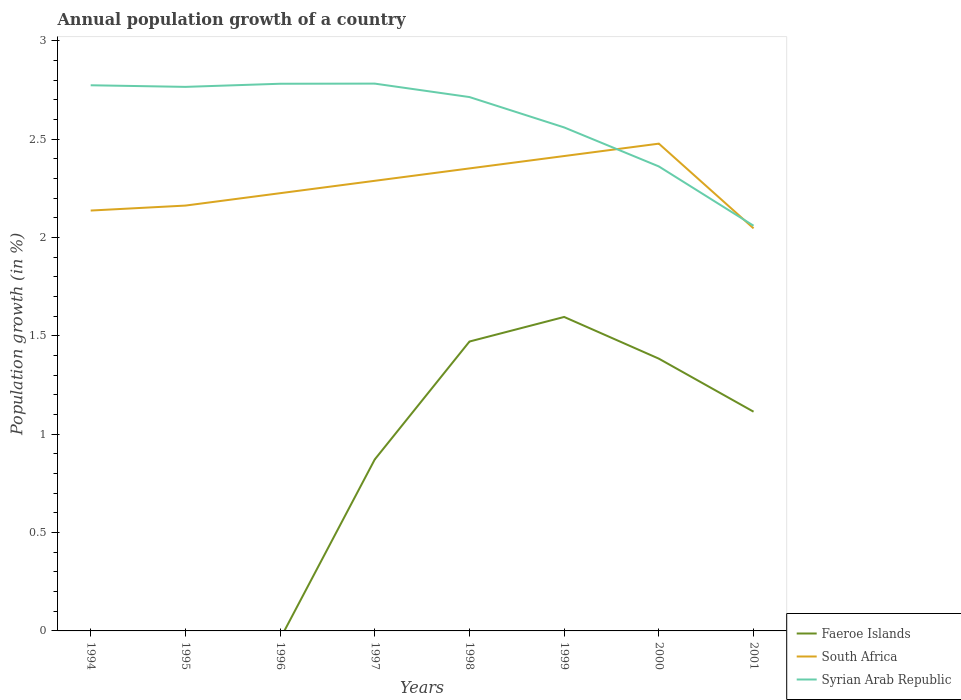How many different coloured lines are there?
Offer a very short reply. 3. Across all years, what is the maximum annual population growth in Faeroe Islands?
Your answer should be compact. 0. What is the total annual population growth in South Africa in the graph?
Provide a succinct answer. -0.15. What is the difference between the highest and the second highest annual population growth in Faeroe Islands?
Ensure brevity in your answer.  1.6. Is the annual population growth in South Africa strictly greater than the annual population growth in Faeroe Islands over the years?
Your answer should be very brief. No. Where does the legend appear in the graph?
Offer a terse response. Bottom right. How many legend labels are there?
Offer a very short reply. 3. How are the legend labels stacked?
Your answer should be very brief. Vertical. What is the title of the graph?
Provide a succinct answer. Annual population growth of a country. What is the label or title of the Y-axis?
Ensure brevity in your answer.  Population growth (in %). What is the Population growth (in %) in Faeroe Islands in 1994?
Your answer should be compact. 0. What is the Population growth (in %) of South Africa in 1994?
Provide a succinct answer. 2.14. What is the Population growth (in %) of Syrian Arab Republic in 1994?
Offer a terse response. 2.77. What is the Population growth (in %) of Faeroe Islands in 1995?
Make the answer very short. 0. What is the Population growth (in %) of South Africa in 1995?
Provide a succinct answer. 2.16. What is the Population growth (in %) of Syrian Arab Republic in 1995?
Provide a succinct answer. 2.77. What is the Population growth (in %) of South Africa in 1996?
Provide a short and direct response. 2.23. What is the Population growth (in %) of Syrian Arab Republic in 1996?
Your answer should be very brief. 2.78. What is the Population growth (in %) in Faeroe Islands in 1997?
Offer a terse response. 0.87. What is the Population growth (in %) of South Africa in 1997?
Offer a terse response. 2.29. What is the Population growth (in %) in Syrian Arab Republic in 1997?
Ensure brevity in your answer.  2.78. What is the Population growth (in %) in Faeroe Islands in 1998?
Ensure brevity in your answer.  1.47. What is the Population growth (in %) of South Africa in 1998?
Give a very brief answer. 2.35. What is the Population growth (in %) of Syrian Arab Republic in 1998?
Your answer should be compact. 2.71. What is the Population growth (in %) of Faeroe Islands in 1999?
Give a very brief answer. 1.6. What is the Population growth (in %) of South Africa in 1999?
Offer a terse response. 2.41. What is the Population growth (in %) of Syrian Arab Republic in 1999?
Ensure brevity in your answer.  2.56. What is the Population growth (in %) of Faeroe Islands in 2000?
Offer a terse response. 1.38. What is the Population growth (in %) in South Africa in 2000?
Offer a very short reply. 2.48. What is the Population growth (in %) of Syrian Arab Republic in 2000?
Your response must be concise. 2.36. What is the Population growth (in %) of Faeroe Islands in 2001?
Offer a very short reply. 1.11. What is the Population growth (in %) of South Africa in 2001?
Provide a succinct answer. 2.05. What is the Population growth (in %) in Syrian Arab Republic in 2001?
Give a very brief answer. 2.06. Across all years, what is the maximum Population growth (in %) of Faeroe Islands?
Your answer should be compact. 1.6. Across all years, what is the maximum Population growth (in %) in South Africa?
Your answer should be compact. 2.48. Across all years, what is the maximum Population growth (in %) in Syrian Arab Republic?
Make the answer very short. 2.78. Across all years, what is the minimum Population growth (in %) of Faeroe Islands?
Offer a terse response. 0. Across all years, what is the minimum Population growth (in %) of South Africa?
Provide a succinct answer. 2.05. Across all years, what is the minimum Population growth (in %) in Syrian Arab Republic?
Provide a succinct answer. 2.06. What is the total Population growth (in %) in Faeroe Islands in the graph?
Provide a short and direct response. 6.44. What is the total Population growth (in %) in South Africa in the graph?
Keep it short and to the point. 18.1. What is the total Population growth (in %) in Syrian Arab Republic in the graph?
Offer a terse response. 20.8. What is the difference between the Population growth (in %) in South Africa in 1994 and that in 1995?
Offer a very short reply. -0.03. What is the difference between the Population growth (in %) in Syrian Arab Republic in 1994 and that in 1995?
Your answer should be compact. 0.01. What is the difference between the Population growth (in %) of South Africa in 1994 and that in 1996?
Your answer should be compact. -0.09. What is the difference between the Population growth (in %) in Syrian Arab Republic in 1994 and that in 1996?
Make the answer very short. -0.01. What is the difference between the Population growth (in %) of South Africa in 1994 and that in 1997?
Provide a succinct answer. -0.15. What is the difference between the Population growth (in %) of Syrian Arab Republic in 1994 and that in 1997?
Your response must be concise. -0.01. What is the difference between the Population growth (in %) of South Africa in 1994 and that in 1998?
Ensure brevity in your answer.  -0.21. What is the difference between the Population growth (in %) of Syrian Arab Republic in 1994 and that in 1998?
Make the answer very short. 0.06. What is the difference between the Population growth (in %) in South Africa in 1994 and that in 1999?
Provide a succinct answer. -0.28. What is the difference between the Population growth (in %) in Syrian Arab Republic in 1994 and that in 1999?
Your answer should be very brief. 0.21. What is the difference between the Population growth (in %) in South Africa in 1994 and that in 2000?
Offer a terse response. -0.34. What is the difference between the Population growth (in %) in Syrian Arab Republic in 1994 and that in 2000?
Make the answer very short. 0.41. What is the difference between the Population growth (in %) of South Africa in 1994 and that in 2001?
Ensure brevity in your answer.  0.09. What is the difference between the Population growth (in %) of Syrian Arab Republic in 1994 and that in 2001?
Provide a succinct answer. 0.71. What is the difference between the Population growth (in %) of South Africa in 1995 and that in 1996?
Provide a short and direct response. -0.06. What is the difference between the Population growth (in %) of Syrian Arab Republic in 1995 and that in 1996?
Give a very brief answer. -0.02. What is the difference between the Population growth (in %) in South Africa in 1995 and that in 1997?
Provide a succinct answer. -0.13. What is the difference between the Population growth (in %) of Syrian Arab Republic in 1995 and that in 1997?
Make the answer very short. -0.02. What is the difference between the Population growth (in %) of South Africa in 1995 and that in 1998?
Provide a short and direct response. -0.19. What is the difference between the Population growth (in %) in Syrian Arab Republic in 1995 and that in 1998?
Offer a terse response. 0.05. What is the difference between the Population growth (in %) of South Africa in 1995 and that in 1999?
Give a very brief answer. -0.25. What is the difference between the Population growth (in %) of Syrian Arab Republic in 1995 and that in 1999?
Provide a short and direct response. 0.21. What is the difference between the Population growth (in %) in South Africa in 1995 and that in 2000?
Provide a short and direct response. -0.31. What is the difference between the Population growth (in %) of Syrian Arab Republic in 1995 and that in 2000?
Make the answer very short. 0.4. What is the difference between the Population growth (in %) in South Africa in 1995 and that in 2001?
Provide a succinct answer. 0.12. What is the difference between the Population growth (in %) of Syrian Arab Republic in 1995 and that in 2001?
Make the answer very short. 0.71. What is the difference between the Population growth (in %) of South Africa in 1996 and that in 1997?
Keep it short and to the point. -0.06. What is the difference between the Population growth (in %) in Syrian Arab Republic in 1996 and that in 1997?
Ensure brevity in your answer.  -0. What is the difference between the Population growth (in %) of South Africa in 1996 and that in 1998?
Your answer should be very brief. -0.13. What is the difference between the Population growth (in %) of Syrian Arab Republic in 1996 and that in 1998?
Your answer should be compact. 0.07. What is the difference between the Population growth (in %) in South Africa in 1996 and that in 1999?
Provide a short and direct response. -0.19. What is the difference between the Population growth (in %) of Syrian Arab Republic in 1996 and that in 1999?
Provide a succinct answer. 0.22. What is the difference between the Population growth (in %) in South Africa in 1996 and that in 2000?
Provide a succinct answer. -0.25. What is the difference between the Population growth (in %) in Syrian Arab Republic in 1996 and that in 2000?
Ensure brevity in your answer.  0.42. What is the difference between the Population growth (in %) of South Africa in 1996 and that in 2001?
Offer a terse response. 0.18. What is the difference between the Population growth (in %) of Syrian Arab Republic in 1996 and that in 2001?
Give a very brief answer. 0.72. What is the difference between the Population growth (in %) of Faeroe Islands in 1997 and that in 1998?
Provide a succinct answer. -0.6. What is the difference between the Population growth (in %) of South Africa in 1997 and that in 1998?
Your answer should be compact. -0.06. What is the difference between the Population growth (in %) in Syrian Arab Republic in 1997 and that in 1998?
Make the answer very short. 0.07. What is the difference between the Population growth (in %) of Faeroe Islands in 1997 and that in 1999?
Provide a succinct answer. -0.72. What is the difference between the Population growth (in %) in South Africa in 1997 and that in 1999?
Make the answer very short. -0.13. What is the difference between the Population growth (in %) of Syrian Arab Republic in 1997 and that in 1999?
Offer a terse response. 0.22. What is the difference between the Population growth (in %) in Faeroe Islands in 1997 and that in 2000?
Your response must be concise. -0.51. What is the difference between the Population growth (in %) of South Africa in 1997 and that in 2000?
Your response must be concise. -0.19. What is the difference between the Population growth (in %) of Syrian Arab Republic in 1997 and that in 2000?
Offer a terse response. 0.42. What is the difference between the Population growth (in %) in Faeroe Islands in 1997 and that in 2001?
Your answer should be compact. -0.24. What is the difference between the Population growth (in %) of South Africa in 1997 and that in 2001?
Offer a terse response. 0.24. What is the difference between the Population growth (in %) in Syrian Arab Republic in 1997 and that in 2001?
Keep it short and to the point. 0.72. What is the difference between the Population growth (in %) of Faeroe Islands in 1998 and that in 1999?
Make the answer very short. -0.12. What is the difference between the Population growth (in %) in South Africa in 1998 and that in 1999?
Provide a succinct answer. -0.06. What is the difference between the Population growth (in %) in Syrian Arab Republic in 1998 and that in 1999?
Your answer should be very brief. 0.15. What is the difference between the Population growth (in %) of Faeroe Islands in 1998 and that in 2000?
Your response must be concise. 0.09. What is the difference between the Population growth (in %) in South Africa in 1998 and that in 2000?
Provide a succinct answer. -0.13. What is the difference between the Population growth (in %) of Syrian Arab Republic in 1998 and that in 2000?
Your answer should be very brief. 0.35. What is the difference between the Population growth (in %) in Faeroe Islands in 1998 and that in 2001?
Keep it short and to the point. 0.36. What is the difference between the Population growth (in %) of South Africa in 1998 and that in 2001?
Your answer should be very brief. 0.3. What is the difference between the Population growth (in %) in Syrian Arab Republic in 1998 and that in 2001?
Your answer should be compact. 0.65. What is the difference between the Population growth (in %) in Faeroe Islands in 1999 and that in 2000?
Ensure brevity in your answer.  0.21. What is the difference between the Population growth (in %) in South Africa in 1999 and that in 2000?
Your answer should be very brief. -0.06. What is the difference between the Population growth (in %) of Syrian Arab Republic in 1999 and that in 2000?
Keep it short and to the point. 0.2. What is the difference between the Population growth (in %) in Faeroe Islands in 1999 and that in 2001?
Ensure brevity in your answer.  0.48. What is the difference between the Population growth (in %) of South Africa in 1999 and that in 2001?
Make the answer very short. 0.37. What is the difference between the Population growth (in %) of Syrian Arab Republic in 1999 and that in 2001?
Keep it short and to the point. 0.5. What is the difference between the Population growth (in %) of Faeroe Islands in 2000 and that in 2001?
Your answer should be compact. 0.27. What is the difference between the Population growth (in %) in South Africa in 2000 and that in 2001?
Your answer should be compact. 0.43. What is the difference between the Population growth (in %) of Syrian Arab Republic in 2000 and that in 2001?
Your response must be concise. 0.3. What is the difference between the Population growth (in %) of South Africa in 1994 and the Population growth (in %) of Syrian Arab Republic in 1995?
Make the answer very short. -0.63. What is the difference between the Population growth (in %) of South Africa in 1994 and the Population growth (in %) of Syrian Arab Republic in 1996?
Your answer should be compact. -0.64. What is the difference between the Population growth (in %) of South Africa in 1994 and the Population growth (in %) of Syrian Arab Republic in 1997?
Ensure brevity in your answer.  -0.65. What is the difference between the Population growth (in %) in South Africa in 1994 and the Population growth (in %) in Syrian Arab Republic in 1998?
Provide a short and direct response. -0.58. What is the difference between the Population growth (in %) in South Africa in 1994 and the Population growth (in %) in Syrian Arab Republic in 1999?
Keep it short and to the point. -0.42. What is the difference between the Population growth (in %) of South Africa in 1994 and the Population growth (in %) of Syrian Arab Republic in 2000?
Offer a terse response. -0.22. What is the difference between the Population growth (in %) of South Africa in 1994 and the Population growth (in %) of Syrian Arab Republic in 2001?
Give a very brief answer. 0.08. What is the difference between the Population growth (in %) in South Africa in 1995 and the Population growth (in %) in Syrian Arab Republic in 1996?
Your answer should be compact. -0.62. What is the difference between the Population growth (in %) of South Africa in 1995 and the Population growth (in %) of Syrian Arab Republic in 1997?
Give a very brief answer. -0.62. What is the difference between the Population growth (in %) of South Africa in 1995 and the Population growth (in %) of Syrian Arab Republic in 1998?
Ensure brevity in your answer.  -0.55. What is the difference between the Population growth (in %) in South Africa in 1995 and the Population growth (in %) in Syrian Arab Republic in 1999?
Make the answer very short. -0.4. What is the difference between the Population growth (in %) in South Africa in 1995 and the Population growth (in %) in Syrian Arab Republic in 2000?
Provide a succinct answer. -0.2. What is the difference between the Population growth (in %) of South Africa in 1995 and the Population growth (in %) of Syrian Arab Republic in 2001?
Your answer should be very brief. 0.1. What is the difference between the Population growth (in %) in South Africa in 1996 and the Population growth (in %) in Syrian Arab Republic in 1997?
Your answer should be compact. -0.56. What is the difference between the Population growth (in %) in South Africa in 1996 and the Population growth (in %) in Syrian Arab Republic in 1998?
Give a very brief answer. -0.49. What is the difference between the Population growth (in %) of South Africa in 1996 and the Population growth (in %) of Syrian Arab Republic in 1999?
Provide a short and direct response. -0.33. What is the difference between the Population growth (in %) in South Africa in 1996 and the Population growth (in %) in Syrian Arab Republic in 2000?
Your answer should be very brief. -0.14. What is the difference between the Population growth (in %) of South Africa in 1996 and the Population growth (in %) of Syrian Arab Republic in 2001?
Give a very brief answer. 0.17. What is the difference between the Population growth (in %) of Faeroe Islands in 1997 and the Population growth (in %) of South Africa in 1998?
Keep it short and to the point. -1.48. What is the difference between the Population growth (in %) of Faeroe Islands in 1997 and the Population growth (in %) of Syrian Arab Republic in 1998?
Your answer should be compact. -1.84. What is the difference between the Population growth (in %) of South Africa in 1997 and the Population growth (in %) of Syrian Arab Republic in 1998?
Your answer should be very brief. -0.43. What is the difference between the Population growth (in %) in Faeroe Islands in 1997 and the Population growth (in %) in South Africa in 1999?
Offer a very short reply. -1.54. What is the difference between the Population growth (in %) of Faeroe Islands in 1997 and the Population growth (in %) of Syrian Arab Republic in 1999?
Make the answer very short. -1.69. What is the difference between the Population growth (in %) of South Africa in 1997 and the Population growth (in %) of Syrian Arab Republic in 1999?
Your response must be concise. -0.27. What is the difference between the Population growth (in %) in Faeroe Islands in 1997 and the Population growth (in %) in South Africa in 2000?
Keep it short and to the point. -1.61. What is the difference between the Population growth (in %) of Faeroe Islands in 1997 and the Population growth (in %) of Syrian Arab Republic in 2000?
Offer a terse response. -1.49. What is the difference between the Population growth (in %) of South Africa in 1997 and the Population growth (in %) of Syrian Arab Republic in 2000?
Offer a terse response. -0.07. What is the difference between the Population growth (in %) of Faeroe Islands in 1997 and the Population growth (in %) of South Africa in 2001?
Offer a very short reply. -1.17. What is the difference between the Population growth (in %) in Faeroe Islands in 1997 and the Population growth (in %) in Syrian Arab Republic in 2001?
Your answer should be very brief. -1.19. What is the difference between the Population growth (in %) of South Africa in 1997 and the Population growth (in %) of Syrian Arab Republic in 2001?
Provide a succinct answer. 0.23. What is the difference between the Population growth (in %) in Faeroe Islands in 1998 and the Population growth (in %) in South Africa in 1999?
Offer a very short reply. -0.94. What is the difference between the Population growth (in %) in Faeroe Islands in 1998 and the Population growth (in %) in Syrian Arab Republic in 1999?
Offer a very short reply. -1.09. What is the difference between the Population growth (in %) in South Africa in 1998 and the Population growth (in %) in Syrian Arab Republic in 1999?
Ensure brevity in your answer.  -0.21. What is the difference between the Population growth (in %) in Faeroe Islands in 1998 and the Population growth (in %) in South Africa in 2000?
Give a very brief answer. -1.01. What is the difference between the Population growth (in %) in Faeroe Islands in 1998 and the Population growth (in %) in Syrian Arab Republic in 2000?
Your answer should be very brief. -0.89. What is the difference between the Population growth (in %) in South Africa in 1998 and the Population growth (in %) in Syrian Arab Republic in 2000?
Provide a short and direct response. -0.01. What is the difference between the Population growth (in %) of Faeroe Islands in 1998 and the Population growth (in %) of South Africa in 2001?
Provide a succinct answer. -0.58. What is the difference between the Population growth (in %) in Faeroe Islands in 1998 and the Population growth (in %) in Syrian Arab Republic in 2001?
Give a very brief answer. -0.59. What is the difference between the Population growth (in %) in South Africa in 1998 and the Population growth (in %) in Syrian Arab Republic in 2001?
Provide a short and direct response. 0.29. What is the difference between the Population growth (in %) in Faeroe Islands in 1999 and the Population growth (in %) in South Africa in 2000?
Keep it short and to the point. -0.88. What is the difference between the Population growth (in %) of Faeroe Islands in 1999 and the Population growth (in %) of Syrian Arab Republic in 2000?
Keep it short and to the point. -0.77. What is the difference between the Population growth (in %) in South Africa in 1999 and the Population growth (in %) in Syrian Arab Republic in 2000?
Your response must be concise. 0.05. What is the difference between the Population growth (in %) of Faeroe Islands in 1999 and the Population growth (in %) of South Africa in 2001?
Provide a succinct answer. -0.45. What is the difference between the Population growth (in %) of Faeroe Islands in 1999 and the Population growth (in %) of Syrian Arab Republic in 2001?
Give a very brief answer. -0.46. What is the difference between the Population growth (in %) in South Africa in 1999 and the Population growth (in %) in Syrian Arab Republic in 2001?
Offer a very short reply. 0.35. What is the difference between the Population growth (in %) in Faeroe Islands in 2000 and the Population growth (in %) in South Africa in 2001?
Offer a terse response. -0.66. What is the difference between the Population growth (in %) in Faeroe Islands in 2000 and the Population growth (in %) in Syrian Arab Republic in 2001?
Keep it short and to the point. -0.68. What is the difference between the Population growth (in %) in South Africa in 2000 and the Population growth (in %) in Syrian Arab Republic in 2001?
Provide a succinct answer. 0.42. What is the average Population growth (in %) of Faeroe Islands per year?
Your answer should be compact. 0.8. What is the average Population growth (in %) of South Africa per year?
Make the answer very short. 2.26. What is the average Population growth (in %) of Syrian Arab Republic per year?
Give a very brief answer. 2.6. In the year 1994, what is the difference between the Population growth (in %) in South Africa and Population growth (in %) in Syrian Arab Republic?
Offer a very short reply. -0.64. In the year 1995, what is the difference between the Population growth (in %) of South Africa and Population growth (in %) of Syrian Arab Republic?
Keep it short and to the point. -0.6. In the year 1996, what is the difference between the Population growth (in %) of South Africa and Population growth (in %) of Syrian Arab Republic?
Ensure brevity in your answer.  -0.56. In the year 1997, what is the difference between the Population growth (in %) of Faeroe Islands and Population growth (in %) of South Africa?
Offer a terse response. -1.42. In the year 1997, what is the difference between the Population growth (in %) of Faeroe Islands and Population growth (in %) of Syrian Arab Republic?
Your answer should be very brief. -1.91. In the year 1997, what is the difference between the Population growth (in %) of South Africa and Population growth (in %) of Syrian Arab Republic?
Offer a very short reply. -0.49. In the year 1998, what is the difference between the Population growth (in %) of Faeroe Islands and Population growth (in %) of South Africa?
Give a very brief answer. -0.88. In the year 1998, what is the difference between the Population growth (in %) in Faeroe Islands and Population growth (in %) in Syrian Arab Republic?
Provide a succinct answer. -1.24. In the year 1998, what is the difference between the Population growth (in %) of South Africa and Population growth (in %) of Syrian Arab Republic?
Your response must be concise. -0.36. In the year 1999, what is the difference between the Population growth (in %) in Faeroe Islands and Population growth (in %) in South Africa?
Keep it short and to the point. -0.82. In the year 1999, what is the difference between the Population growth (in %) of Faeroe Islands and Population growth (in %) of Syrian Arab Republic?
Make the answer very short. -0.96. In the year 1999, what is the difference between the Population growth (in %) in South Africa and Population growth (in %) in Syrian Arab Republic?
Your response must be concise. -0.15. In the year 2000, what is the difference between the Population growth (in %) in Faeroe Islands and Population growth (in %) in South Africa?
Your answer should be compact. -1.09. In the year 2000, what is the difference between the Population growth (in %) of Faeroe Islands and Population growth (in %) of Syrian Arab Republic?
Offer a very short reply. -0.98. In the year 2000, what is the difference between the Population growth (in %) in South Africa and Population growth (in %) in Syrian Arab Republic?
Keep it short and to the point. 0.12. In the year 2001, what is the difference between the Population growth (in %) of Faeroe Islands and Population growth (in %) of South Africa?
Your response must be concise. -0.93. In the year 2001, what is the difference between the Population growth (in %) in Faeroe Islands and Population growth (in %) in Syrian Arab Republic?
Your answer should be compact. -0.95. In the year 2001, what is the difference between the Population growth (in %) of South Africa and Population growth (in %) of Syrian Arab Republic?
Your answer should be compact. -0.01. What is the ratio of the Population growth (in %) in South Africa in 1994 to that in 1995?
Offer a terse response. 0.99. What is the ratio of the Population growth (in %) of South Africa in 1994 to that in 1996?
Provide a succinct answer. 0.96. What is the ratio of the Population growth (in %) of Syrian Arab Republic in 1994 to that in 1996?
Your response must be concise. 1. What is the ratio of the Population growth (in %) of South Africa in 1994 to that in 1997?
Your answer should be very brief. 0.93. What is the ratio of the Population growth (in %) in South Africa in 1994 to that in 1998?
Offer a terse response. 0.91. What is the ratio of the Population growth (in %) of Syrian Arab Republic in 1994 to that in 1998?
Offer a terse response. 1.02. What is the ratio of the Population growth (in %) of South Africa in 1994 to that in 1999?
Keep it short and to the point. 0.89. What is the ratio of the Population growth (in %) in Syrian Arab Republic in 1994 to that in 1999?
Your answer should be very brief. 1.08. What is the ratio of the Population growth (in %) of South Africa in 1994 to that in 2000?
Give a very brief answer. 0.86. What is the ratio of the Population growth (in %) of Syrian Arab Republic in 1994 to that in 2000?
Ensure brevity in your answer.  1.17. What is the ratio of the Population growth (in %) of South Africa in 1994 to that in 2001?
Your answer should be very brief. 1.04. What is the ratio of the Population growth (in %) of Syrian Arab Republic in 1994 to that in 2001?
Make the answer very short. 1.35. What is the ratio of the Population growth (in %) of South Africa in 1995 to that in 1996?
Provide a succinct answer. 0.97. What is the ratio of the Population growth (in %) in Syrian Arab Republic in 1995 to that in 1996?
Make the answer very short. 0.99. What is the ratio of the Population growth (in %) of South Africa in 1995 to that in 1997?
Offer a terse response. 0.94. What is the ratio of the Population growth (in %) in South Africa in 1995 to that in 1998?
Your answer should be compact. 0.92. What is the ratio of the Population growth (in %) in Syrian Arab Republic in 1995 to that in 1998?
Make the answer very short. 1.02. What is the ratio of the Population growth (in %) in South Africa in 1995 to that in 1999?
Your response must be concise. 0.9. What is the ratio of the Population growth (in %) of Syrian Arab Republic in 1995 to that in 1999?
Ensure brevity in your answer.  1.08. What is the ratio of the Population growth (in %) of South Africa in 1995 to that in 2000?
Make the answer very short. 0.87. What is the ratio of the Population growth (in %) of Syrian Arab Republic in 1995 to that in 2000?
Your answer should be compact. 1.17. What is the ratio of the Population growth (in %) in South Africa in 1995 to that in 2001?
Your response must be concise. 1.06. What is the ratio of the Population growth (in %) of Syrian Arab Republic in 1995 to that in 2001?
Give a very brief answer. 1.34. What is the ratio of the Population growth (in %) of South Africa in 1996 to that in 1997?
Offer a terse response. 0.97. What is the ratio of the Population growth (in %) in Syrian Arab Republic in 1996 to that in 1997?
Ensure brevity in your answer.  1. What is the ratio of the Population growth (in %) in South Africa in 1996 to that in 1998?
Your response must be concise. 0.95. What is the ratio of the Population growth (in %) of Syrian Arab Republic in 1996 to that in 1998?
Your answer should be compact. 1.02. What is the ratio of the Population growth (in %) of South Africa in 1996 to that in 1999?
Offer a terse response. 0.92. What is the ratio of the Population growth (in %) in Syrian Arab Republic in 1996 to that in 1999?
Your answer should be compact. 1.09. What is the ratio of the Population growth (in %) of South Africa in 1996 to that in 2000?
Offer a very short reply. 0.9. What is the ratio of the Population growth (in %) in Syrian Arab Republic in 1996 to that in 2000?
Your answer should be compact. 1.18. What is the ratio of the Population growth (in %) of South Africa in 1996 to that in 2001?
Offer a very short reply. 1.09. What is the ratio of the Population growth (in %) in Syrian Arab Republic in 1996 to that in 2001?
Offer a terse response. 1.35. What is the ratio of the Population growth (in %) of Faeroe Islands in 1997 to that in 1998?
Provide a short and direct response. 0.59. What is the ratio of the Population growth (in %) in South Africa in 1997 to that in 1998?
Give a very brief answer. 0.97. What is the ratio of the Population growth (in %) of Syrian Arab Republic in 1997 to that in 1998?
Keep it short and to the point. 1.03. What is the ratio of the Population growth (in %) of Faeroe Islands in 1997 to that in 1999?
Your response must be concise. 0.55. What is the ratio of the Population growth (in %) in South Africa in 1997 to that in 1999?
Give a very brief answer. 0.95. What is the ratio of the Population growth (in %) in Syrian Arab Republic in 1997 to that in 1999?
Offer a very short reply. 1.09. What is the ratio of the Population growth (in %) of Faeroe Islands in 1997 to that in 2000?
Your answer should be compact. 0.63. What is the ratio of the Population growth (in %) of South Africa in 1997 to that in 2000?
Make the answer very short. 0.92. What is the ratio of the Population growth (in %) in Syrian Arab Republic in 1997 to that in 2000?
Your response must be concise. 1.18. What is the ratio of the Population growth (in %) in Faeroe Islands in 1997 to that in 2001?
Your answer should be very brief. 0.78. What is the ratio of the Population growth (in %) in South Africa in 1997 to that in 2001?
Make the answer very short. 1.12. What is the ratio of the Population growth (in %) in Syrian Arab Republic in 1997 to that in 2001?
Offer a terse response. 1.35. What is the ratio of the Population growth (in %) of Faeroe Islands in 1998 to that in 1999?
Provide a succinct answer. 0.92. What is the ratio of the Population growth (in %) of South Africa in 1998 to that in 1999?
Offer a terse response. 0.97. What is the ratio of the Population growth (in %) in Syrian Arab Republic in 1998 to that in 1999?
Provide a succinct answer. 1.06. What is the ratio of the Population growth (in %) in Faeroe Islands in 1998 to that in 2000?
Offer a terse response. 1.06. What is the ratio of the Population growth (in %) in South Africa in 1998 to that in 2000?
Provide a short and direct response. 0.95. What is the ratio of the Population growth (in %) in Syrian Arab Republic in 1998 to that in 2000?
Give a very brief answer. 1.15. What is the ratio of the Population growth (in %) of Faeroe Islands in 1998 to that in 2001?
Your answer should be very brief. 1.32. What is the ratio of the Population growth (in %) of South Africa in 1998 to that in 2001?
Offer a very short reply. 1.15. What is the ratio of the Population growth (in %) of Syrian Arab Republic in 1998 to that in 2001?
Your answer should be very brief. 1.32. What is the ratio of the Population growth (in %) of Faeroe Islands in 1999 to that in 2000?
Your response must be concise. 1.15. What is the ratio of the Population growth (in %) of South Africa in 1999 to that in 2000?
Your answer should be very brief. 0.97. What is the ratio of the Population growth (in %) of Syrian Arab Republic in 1999 to that in 2000?
Your answer should be very brief. 1.08. What is the ratio of the Population growth (in %) in Faeroe Islands in 1999 to that in 2001?
Keep it short and to the point. 1.43. What is the ratio of the Population growth (in %) in South Africa in 1999 to that in 2001?
Give a very brief answer. 1.18. What is the ratio of the Population growth (in %) of Syrian Arab Republic in 1999 to that in 2001?
Make the answer very short. 1.24. What is the ratio of the Population growth (in %) of Faeroe Islands in 2000 to that in 2001?
Offer a terse response. 1.24. What is the ratio of the Population growth (in %) of South Africa in 2000 to that in 2001?
Your answer should be compact. 1.21. What is the ratio of the Population growth (in %) of Syrian Arab Republic in 2000 to that in 2001?
Make the answer very short. 1.15. What is the difference between the highest and the second highest Population growth (in %) in Faeroe Islands?
Offer a very short reply. 0.12. What is the difference between the highest and the second highest Population growth (in %) of South Africa?
Make the answer very short. 0.06. What is the difference between the highest and the second highest Population growth (in %) in Syrian Arab Republic?
Provide a short and direct response. 0. What is the difference between the highest and the lowest Population growth (in %) in Faeroe Islands?
Your answer should be very brief. 1.6. What is the difference between the highest and the lowest Population growth (in %) of South Africa?
Provide a succinct answer. 0.43. What is the difference between the highest and the lowest Population growth (in %) in Syrian Arab Republic?
Ensure brevity in your answer.  0.72. 